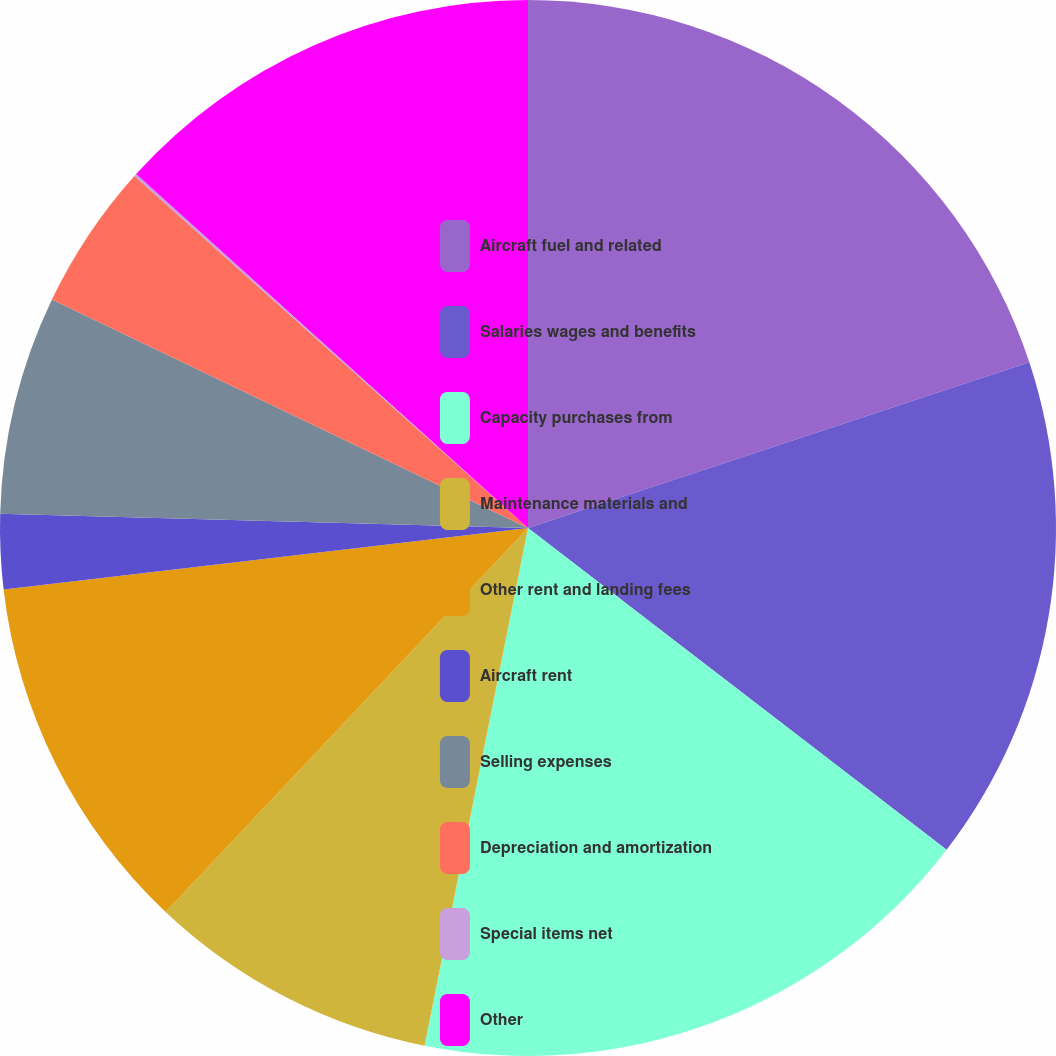Convert chart to OTSL. <chart><loc_0><loc_0><loc_500><loc_500><pie_chart><fcel>Aircraft fuel and related<fcel>Salaries wages and benefits<fcel>Capacity purchases from<fcel>Maintenance materials and<fcel>Other rent and landing fees<fcel>Aircraft rent<fcel>Selling expenses<fcel>Depreciation and amortization<fcel>Special items net<fcel>Other<nl><fcel>19.92%<fcel>15.51%<fcel>17.71%<fcel>8.9%<fcel>11.1%<fcel>2.29%<fcel>6.69%<fcel>4.49%<fcel>0.08%<fcel>13.31%<nl></chart> 